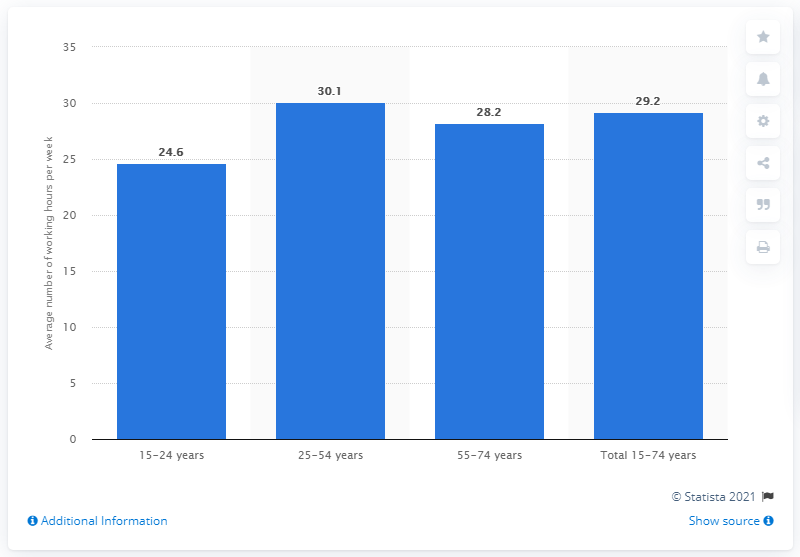Outline some significant characteristics in this image. The average of two medians is 28.7. The average 25 to 54 year olds worked approximately 30.1 hours per week. The age group with a working hour of 30.1 is 25-54 years old. 